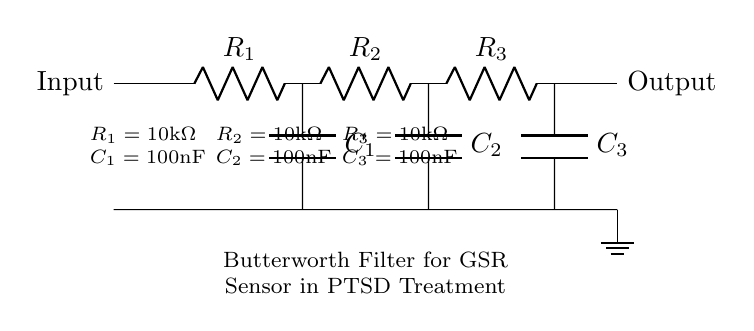What type of filter is displayed in the circuit? The circuit shown is a Butterworth filter, characterized by its smooth frequency response without ripple in the passband. This is indicated by the title in the circuit diagram that specifies "Butterworth Filter".
Answer: Butterworth filter How many resistors are present in the circuit? The circuit diagram clearly displays three resistors labeled R1, R2, and R3. This can be verified by counting the components in the visual.
Answer: Three What is the value of each resistor in the circuit? Each resistor in the circuit is labeled with the same value of ten thousand ohms, indicated as 10k Ohm next to each resistor in the diagram.
Answer: Ten thousand Ohms What is the capacitance value for C1? The circuit diagram shows that capacitor C1 has a labeled capacitance of 100 nanofarads, which can be found next to the component in the visual representation.
Answer: One hundred nanofarads What function do the capacitors serve in the Butterworth filter circuit? The capacitors in the Butterworth filter are primarily responsible for smoothing the signal, contributing to the filter's roll-off characteristics and aiding in phase shifting. This function is inherent to the design of the filter.
Answer: Smoothing the signal What is the output location in the circuit? The output of the circuit is indicated by a label on the right side marked "Output". This is where the processed and filtered signals can be taken from.
Answer: Output What is the role of resistors and capacitors combined in this filter? The combination of resistors and capacitors in this circuit forms a low-pass filter that effectively attenuates high-frequency signals while allowing lower frequencies to pass through. This is characteristic of a Butterworth filter's behavior.
Answer: Attenuation of high frequencies 